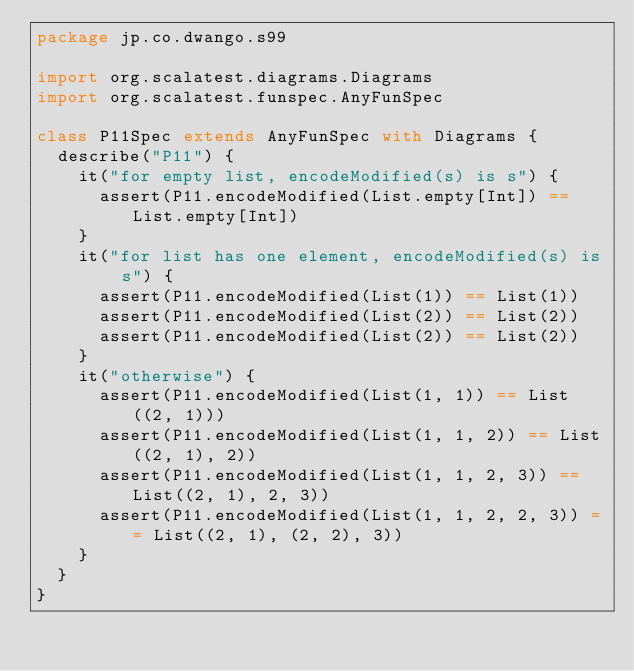Convert code to text. <code><loc_0><loc_0><loc_500><loc_500><_Scala_>package jp.co.dwango.s99

import org.scalatest.diagrams.Diagrams
import org.scalatest.funspec.AnyFunSpec

class P11Spec extends AnyFunSpec with Diagrams {
  describe("P11") {
    it("for empty list, encodeModified(s) is s") {
      assert(P11.encodeModified(List.empty[Int]) == List.empty[Int])
    }
    it("for list has one element, encodeModified(s) is s") {
      assert(P11.encodeModified(List(1)) == List(1))
      assert(P11.encodeModified(List(2)) == List(2))
      assert(P11.encodeModified(List(2)) == List(2))
    }
    it("otherwise") {
      assert(P11.encodeModified(List(1, 1)) == List((2, 1)))
      assert(P11.encodeModified(List(1, 1, 2)) == List((2, 1), 2))
      assert(P11.encodeModified(List(1, 1, 2, 3)) == List((2, 1), 2, 3))
      assert(P11.encodeModified(List(1, 1, 2, 2, 3)) == List((2, 1), (2, 2), 3))
    }
  }
}
</code> 